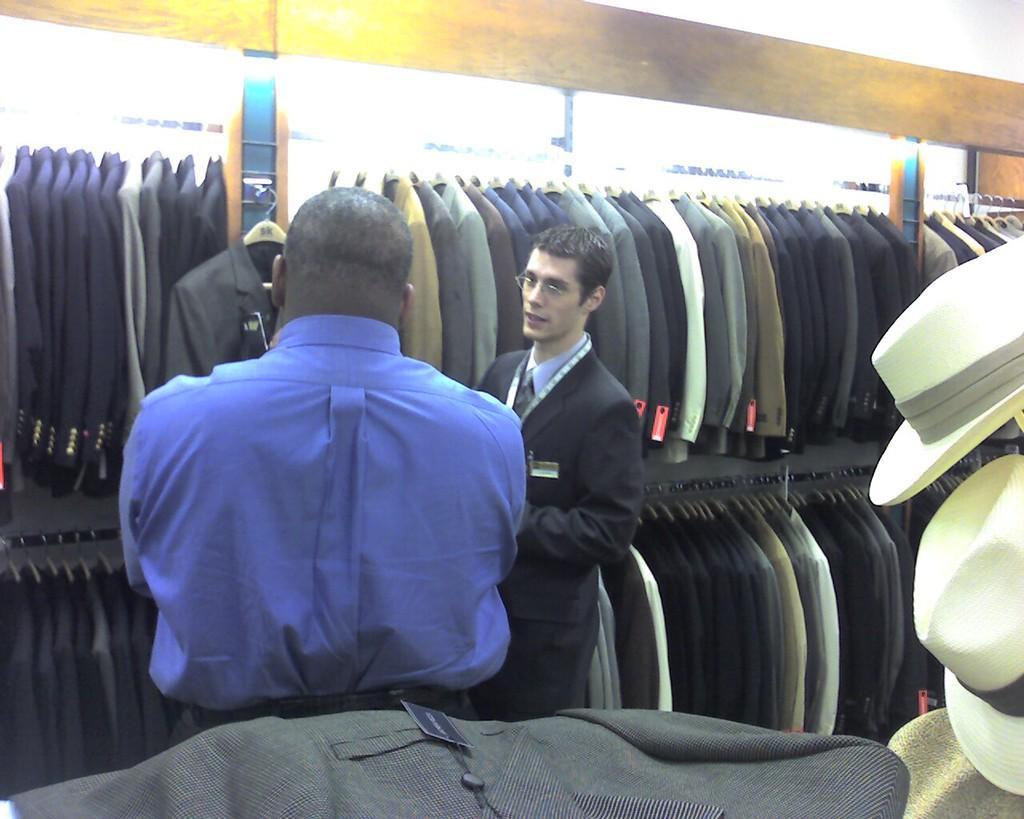Could you give a brief overview of what you see in this image? In this image I can see two persons are standing on the floor, clothes, hats and suits are hanged in a shelves. In the background I can see a wall, lights. This image is taken may be in a shop. 